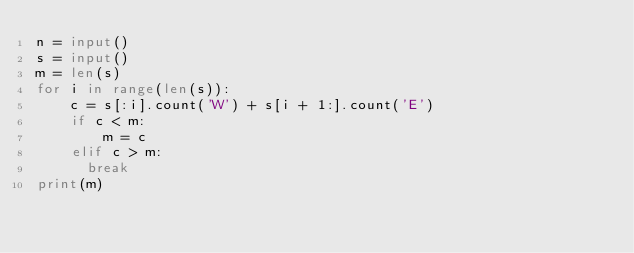<code> <loc_0><loc_0><loc_500><loc_500><_Python_>n = input()
s = input()
m = len(s)
for i in range(len(s)):
    c = s[:i].count('W') + s[i + 1:].count('E')
    if c < m:
        m = c
    elif c > m:
      break
print(m)</code> 